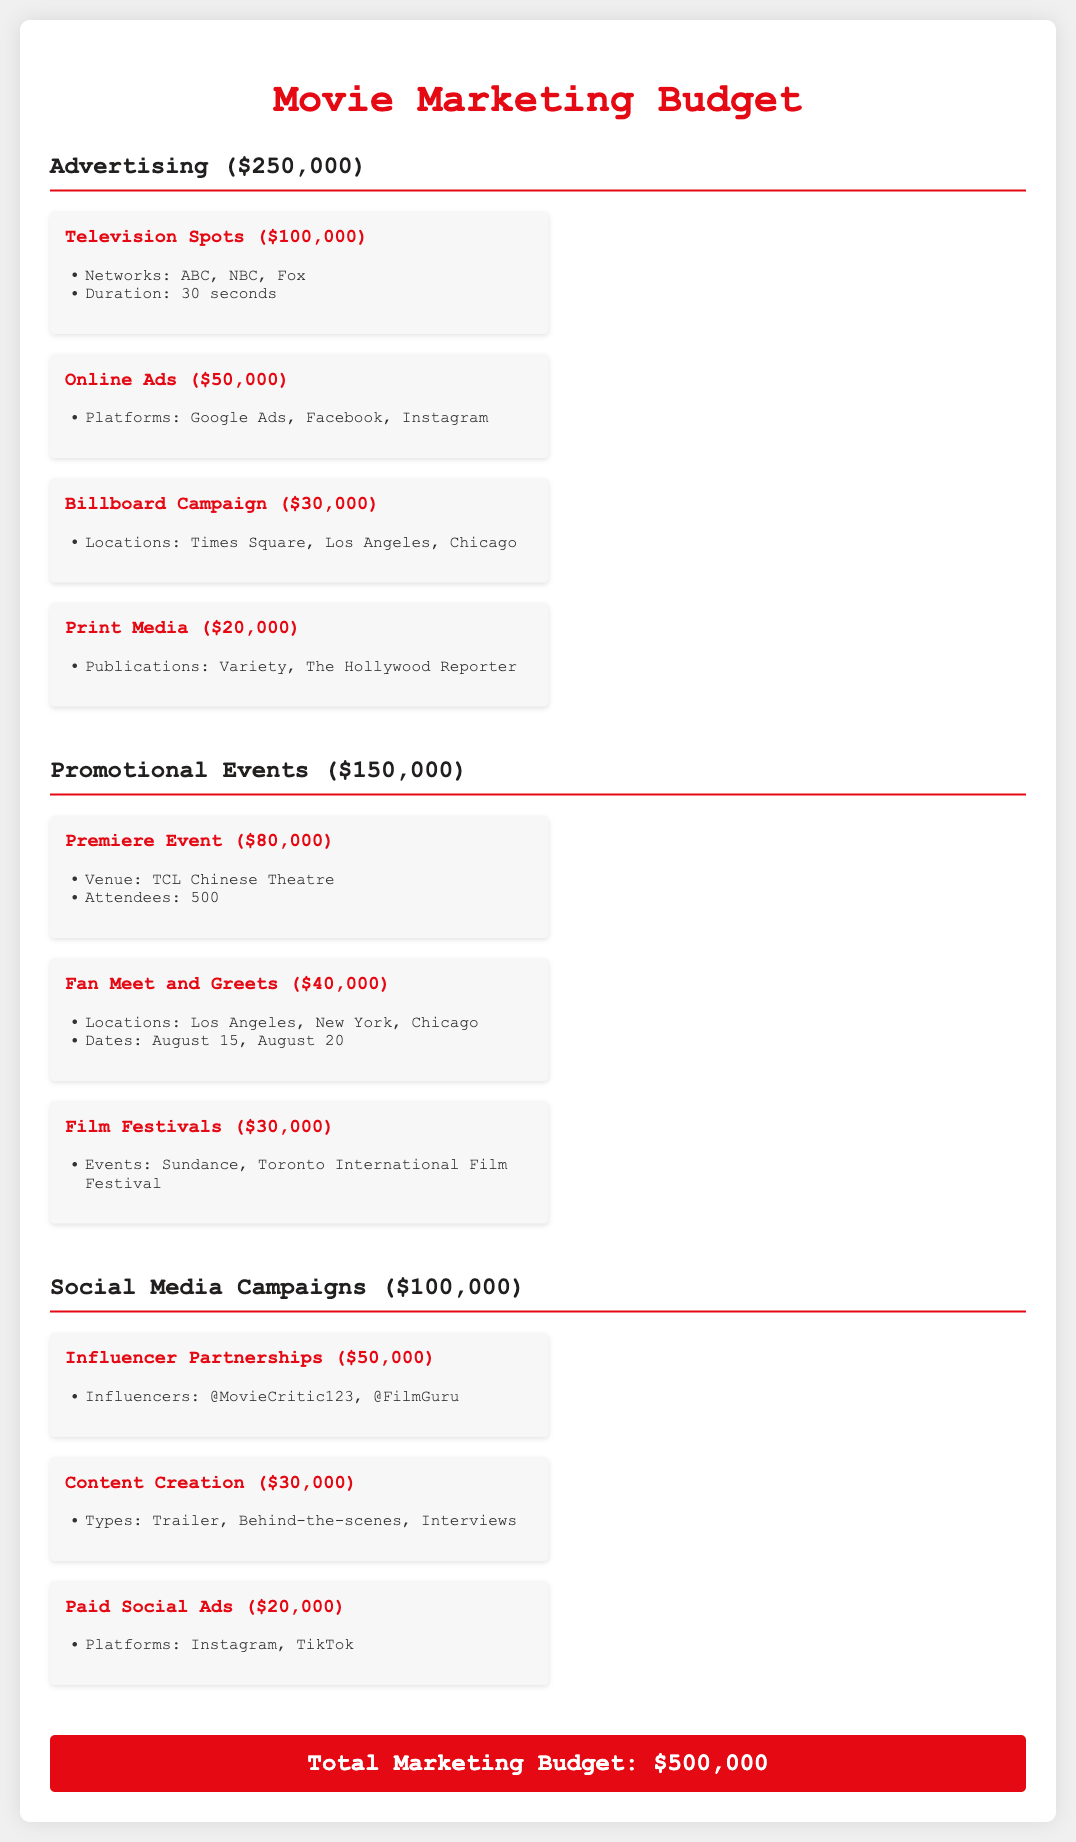What is the total marketing budget? The total marketing budget is presented at the bottom of the document as the sum of all sections, which is $500,000.
Answer: $500,000 How much does the television spots expense amount to? The television spots expense is listed under the advertising section with a specific amount of $100,000.
Answer: $100,000 What are the locations for the billboard campaign? The billboard campaign specifies three locations in the budget section, which are Times Square, Los Angeles, and Chicago.
Answer: Times Square, Los Angeles, Chicago How much is allocated for influencer partnerships? The influencer partnerships are detailed in the social media campaigns section and are allocated $50,000.
Answer: $50,000 What is the venue for the premiere event? The budget provides specific details about the premiere event, noting that the venue is the TCL Chinese Theatre.
Answer: TCL Chinese Theatre How many attendees are expected at the premiere event? The document states that the expected number of attendees at the premiere event is 500.
Answer: 500 What is the total amount allocated for promotional events? The total for promotional events is calculated from the individual expenses, amounting to $150,000.
Answer: $150,000 What types of content are included in content creation? The content creation mentions specific types that are part of the budget, including Trailer, Behind-the-scenes, and Interviews.
Answer: Trailer, Behind-the-scenes, Interviews How much is allocated for paid social ads? The budget outlines that the expense for paid social ads is $20,000 under the social media campaigns section.
Answer: $20,000 